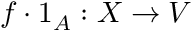Convert formula to latex. <formula><loc_0><loc_0><loc_500><loc_500>f \cdot 1 _ { A } \colon X \to V</formula> 